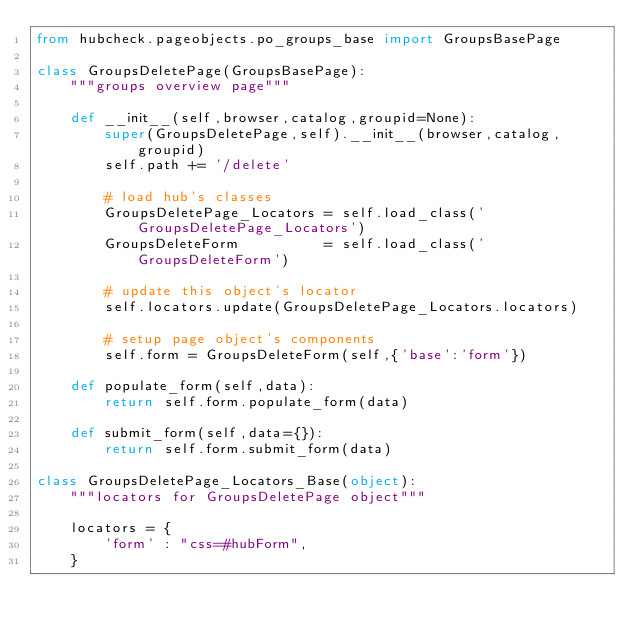Convert code to text. <code><loc_0><loc_0><loc_500><loc_500><_Python_>from hubcheck.pageobjects.po_groups_base import GroupsBasePage

class GroupsDeletePage(GroupsBasePage):
    """groups overview page"""

    def __init__(self,browser,catalog,groupid=None):
        super(GroupsDeletePage,self).__init__(browser,catalog,groupid)
        self.path += '/delete'

        # load hub's classes
        GroupsDeletePage_Locators = self.load_class('GroupsDeletePage_Locators')
        GroupsDeleteForm          = self.load_class('GroupsDeleteForm')

        # update this object's locator
        self.locators.update(GroupsDeletePage_Locators.locators)

        # setup page object's components
        self.form = GroupsDeleteForm(self,{'base':'form'})

    def populate_form(self,data):
        return self.form.populate_form(data)

    def submit_form(self,data={}):
        return self.form.submit_form(data)

class GroupsDeletePage_Locators_Base(object):
    """locators for GroupsDeletePage object"""

    locators = {
        'form' : "css=#hubForm",
    }
</code> 